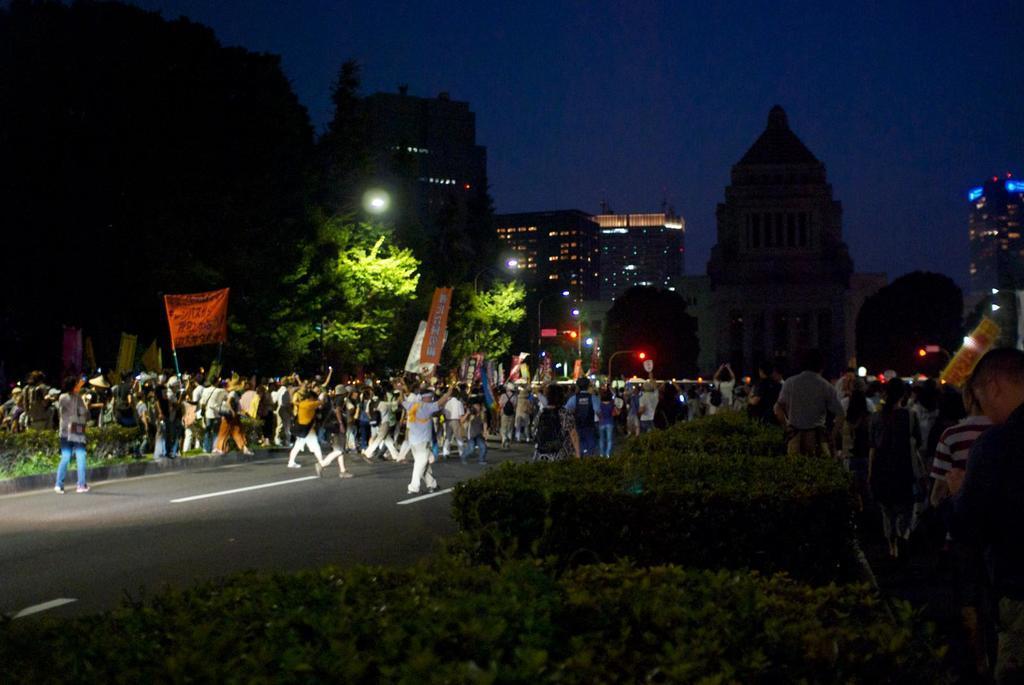Describe this image in one or two sentences. In this image in the front there are plants and in the background there are persons walking and there are persons holding banners with some text written on it and there are trees, buildings and there are light poles. 